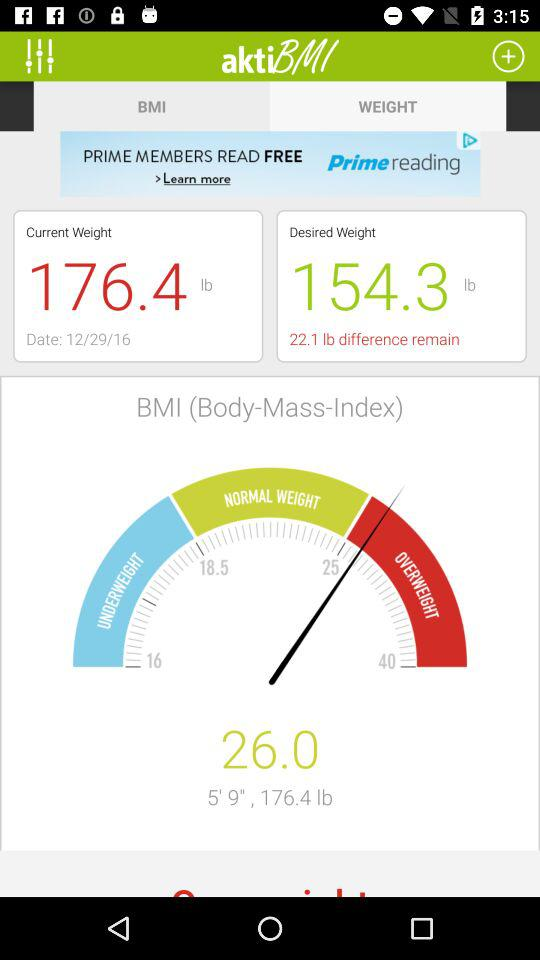What is height in BMI? The height in BMI is 5 feet and 9 inches. 